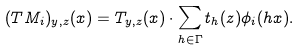<formula> <loc_0><loc_0><loc_500><loc_500>( T M _ { i } ) _ { y , z } ( x ) = T _ { y , z } ( x ) \cdot \sum _ { h \in \Gamma } t _ { h } ( z ) \phi _ { i } ( h x ) .</formula> 